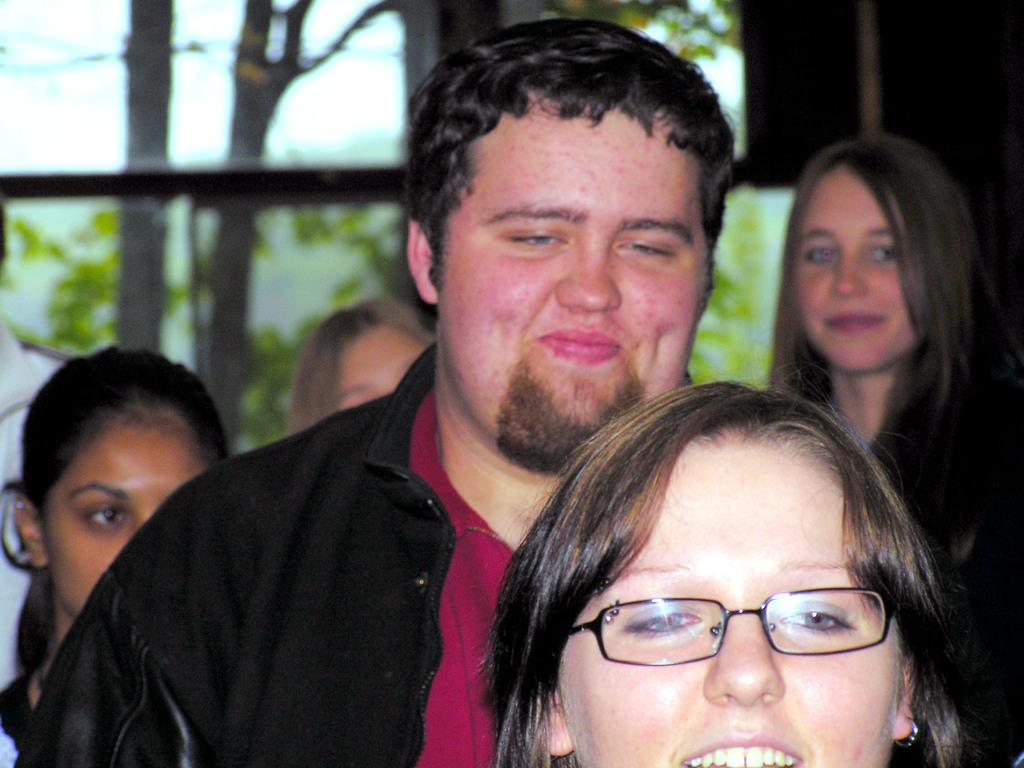How many people are in the image? There is a group of people in the image, but the exact number cannot be determined from the provided facts. What can be seen in the background of the image? Branches and leaves are visible in the background of the image. How are the branches and leaves visible in the image? The branches and leaves are seen through a transparent glass. What type of line is being used to create shade in the image? There is no mention of a line or shade being used in the image; it features a group of people with branches and leaves visible in the background through a transparent glass. 